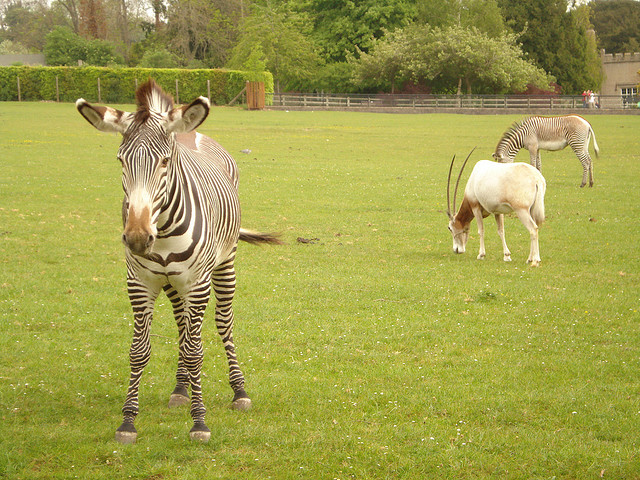<image>What species of Zebra are in the photo? I don't know what species of Zebra are in the photo. It might be a regular zebra or a plains zebra. What species of Zebra are in the photo? I am not sure what species of Zebra are in the photo. It can be African, Plains Zebra or Regular Zebra. 